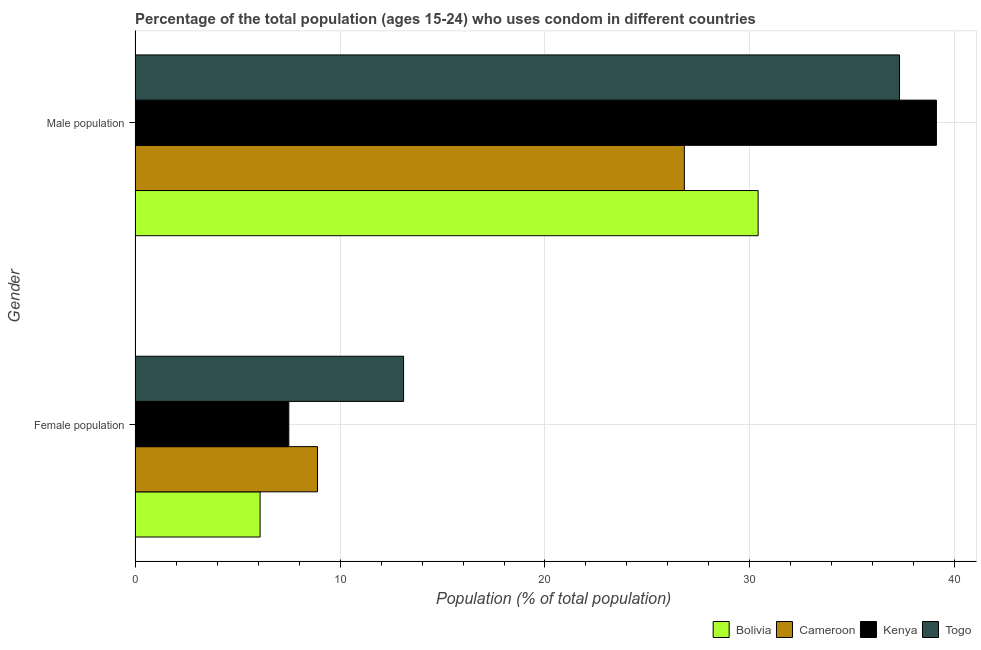How many different coloured bars are there?
Your answer should be compact. 4. How many groups of bars are there?
Offer a very short reply. 2. Are the number of bars per tick equal to the number of legend labels?
Offer a very short reply. Yes. How many bars are there on the 2nd tick from the top?
Your answer should be very brief. 4. What is the label of the 1st group of bars from the top?
Keep it short and to the point. Male population. What is the male population in Bolivia?
Give a very brief answer. 30.4. Across all countries, what is the maximum male population?
Make the answer very short. 39.1. Across all countries, what is the minimum female population?
Make the answer very short. 6.1. In which country was the male population maximum?
Provide a succinct answer. Kenya. In which country was the male population minimum?
Provide a succinct answer. Cameroon. What is the total male population in the graph?
Offer a very short reply. 133.6. What is the difference between the female population in Cameroon and that in Kenya?
Offer a terse response. 1.4. What is the difference between the female population in Bolivia and the male population in Togo?
Ensure brevity in your answer.  -31.2. What is the average male population per country?
Make the answer very short. 33.4. What is the difference between the female population and male population in Togo?
Keep it short and to the point. -24.2. What is the ratio of the male population in Bolivia to that in Togo?
Your answer should be very brief. 0.82. Is the female population in Cameroon less than that in Togo?
Ensure brevity in your answer.  Yes. What does the 1st bar from the top in Female population represents?
Keep it short and to the point. Togo. What does the 3rd bar from the bottom in Male population represents?
Your answer should be very brief. Kenya. How many bars are there?
Offer a terse response. 8. Are all the bars in the graph horizontal?
Your answer should be compact. Yes. How many countries are there in the graph?
Provide a succinct answer. 4. Are the values on the major ticks of X-axis written in scientific E-notation?
Your answer should be compact. No. Does the graph contain any zero values?
Give a very brief answer. No. Does the graph contain grids?
Offer a terse response. Yes. Where does the legend appear in the graph?
Give a very brief answer. Bottom right. How are the legend labels stacked?
Give a very brief answer. Horizontal. What is the title of the graph?
Keep it short and to the point. Percentage of the total population (ages 15-24) who uses condom in different countries. Does "Guatemala" appear as one of the legend labels in the graph?
Your answer should be very brief. No. What is the label or title of the X-axis?
Your response must be concise. Population (% of total population) . What is the Population (% of total population)  in Cameroon in Female population?
Provide a short and direct response. 8.9. What is the Population (% of total population)  in Bolivia in Male population?
Your response must be concise. 30.4. What is the Population (% of total population)  of Cameroon in Male population?
Offer a terse response. 26.8. What is the Population (% of total population)  in Kenya in Male population?
Your answer should be very brief. 39.1. What is the Population (% of total population)  of Togo in Male population?
Keep it short and to the point. 37.3. Across all Gender, what is the maximum Population (% of total population)  in Bolivia?
Your answer should be compact. 30.4. Across all Gender, what is the maximum Population (% of total population)  in Cameroon?
Ensure brevity in your answer.  26.8. Across all Gender, what is the maximum Population (% of total population)  of Kenya?
Give a very brief answer. 39.1. Across all Gender, what is the maximum Population (% of total population)  in Togo?
Ensure brevity in your answer.  37.3. Across all Gender, what is the minimum Population (% of total population)  of Bolivia?
Your response must be concise. 6.1. Across all Gender, what is the minimum Population (% of total population)  in Cameroon?
Your answer should be very brief. 8.9. Across all Gender, what is the minimum Population (% of total population)  in Kenya?
Provide a succinct answer. 7.5. What is the total Population (% of total population)  in Bolivia in the graph?
Offer a very short reply. 36.5. What is the total Population (% of total population)  of Cameroon in the graph?
Make the answer very short. 35.7. What is the total Population (% of total population)  in Kenya in the graph?
Provide a succinct answer. 46.6. What is the total Population (% of total population)  of Togo in the graph?
Provide a succinct answer. 50.4. What is the difference between the Population (% of total population)  of Bolivia in Female population and that in Male population?
Make the answer very short. -24.3. What is the difference between the Population (% of total population)  in Cameroon in Female population and that in Male population?
Keep it short and to the point. -17.9. What is the difference between the Population (% of total population)  in Kenya in Female population and that in Male population?
Offer a very short reply. -31.6. What is the difference between the Population (% of total population)  in Togo in Female population and that in Male population?
Keep it short and to the point. -24.2. What is the difference between the Population (% of total population)  of Bolivia in Female population and the Population (% of total population)  of Cameroon in Male population?
Give a very brief answer. -20.7. What is the difference between the Population (% of total population)  of Bolivia in Female population and the Population (% of total population)  of Kenya in Male population?
Give a very brief answer. -33. What is the difference between the Population (% of total population)  of Bolivia in Female population and the Population (% of total population)  of Togo in Male population?
Offer a terse response. -31.2. What is the difference between the Population (% of total population)  in Cameroon in Female population and the Population (% of total population)  in Kenya in Male population?
Offer a very short reply. -30.2. What is the difference between the Population (% of total population)  in Cameroon in Female population and the Population (% of total population)  in Togo in Male population?
Your answer should be compact. -28.4. What is the difference between the Population (% of total population)  of Kenya in Female population and the Population (% of total population)  of Togo in Male population?
Your answer should be very brief. -29.8. What is the average Population (% of total population)  in Bolivia per Gender?
Offer a very short reply. 18.25. What is the average Population (% of total population)  of Cameroon per Gender?
Give a very brief answer. 17.85. What is the average Population (% of total population)  of Kenya per Gender?
Provide a succinct answer. 23.3. What is the average Population (% of total population)  in Togo per Gender?
Offer a terse response. 25.2. What is the difference between the Population (% of total population)  of Bolivia and Population (% of total population)  of Cameroon in Female population?
Keep it short and to the point. -2.8. What is the difference between the Population (% of total population)  of Bolivia and Population (% of total population)  of Kenya in Female population?
Keep it short and to the point. -1.4. What is the difference between the Population (% of total population)  of Bolivia and Population (% of total population)  of Togo in Female population?
Offer a terse response. -7. What is the difference between the Population (% of total population)  in Cameroon and Population (% of total population)  in Kenya in Female population?
Ensure brevity in your answer.  1.4. What is the difference between the Population (% of total population)  of Cameroon and Population (% of total population)  of Kenya in Male population?
Your answer should be compact. -12.3. What is the difference between the Population (% of total population)  of Cameroon and Population (% of total population)  of Togo in Male population?
Your answer should be very brief. -10.5. What is the difference between the Population (% of total population)  in Kenya and Population (% of total population)  in Togo in Male population?
Keep it short and to the point. 1.8. What is the ratio of the Population (% of total population)  in Bolivia in Female population to that in Male population?
Give a very brief answer. 0.2. What is the ratio of the Population (% of total population)  in Cameroon in Female population to that in Male population?
Make the answer very short. 0.33. What is the ratio of the Population (% of total population)  of Kenya in Female population to that in Male population?
Give a very brief answer. 0.19. What is the ratio of the Population (% of total population)  of Togo in Female population to that in Male population?
Your answer should be very brief. 0.35. What is the difference between the highest and the second highest Population (% of total population)  of Bolivia?
Offer a terse response. 24.3. What is the difference between the highest and the second highest Population (% of total population)  in Cameroon?
Your response must be concise. 17.9. What is the difference between the highest and the second highest Population (% of total population)  in Kenya?
Your response must be concise. 31.6. What is the difference between the highest and the second highest Population (% of total population)  of Togo?
Make the answer very short. 24.2. What is the difference between the highest and the lowest Population (% of total population)  of Bolivia?
Your answer should be very brief. 24.3. What is the difference between the highest and the lowest Population (% of total population)  of Kenya?
Offer a terse response. 31.6. What is the difference between the highest and the lowest Population (% of total population)  of Togo?
Make the answer very short. 24.2. 